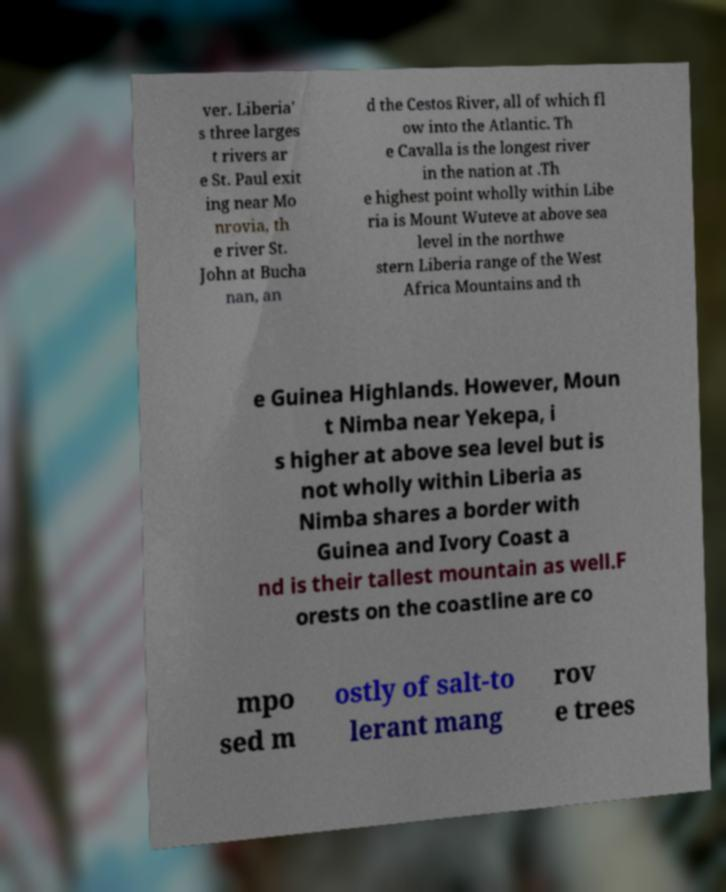Can you accurately transcribe the text from the provided image for me? ver. Liberia' s three larges t rivers ar e St. Paul exit ing near Mo nrovia, th e river St. John at Bucha nan, an d the Cestos River, all of which fl ow into the Atlantic. Th e Cavalla is the longest river in the nation at .Th e highest point wholly within Libe ria is Mount Wuteve at above sea level in the northwe stern Liberia range of the West Africa Mountains and th e Guinea Highlands. However, Moun t Nimba near Yekepa, i s higher at above sea level but is not wholly within Liberia as Nimba shares a border with Guinea and Ivory Coast a nd is their tallest mountain as well.F orests on the coastline are co mpo sed m ostly of salt-to lerant mang rov e trees 